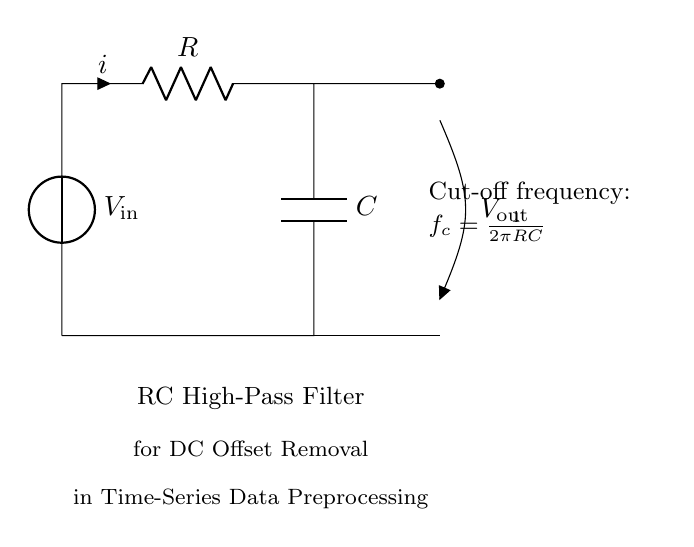What is the input voltage of the circuit? The input voltage is represented as V_in at the top of the voltage source in the circuit.
Answer: V_in What components are used in the circuit? The circuit consists of a voltage source, a resistor, and a capacitor, as depicted in the diagram.
Answer: Voltage source, resistor, capacitor What does the current direction indicate? The direction indicated by the arrow on the resistor shows the flow of current from the voltage source through the resistor and towards the capacitor.
Answer: From the voltage source through the resistor to the capacitor What is the formula for the cut-off frequency? The cut-off frequency, shown in the diagram, is given by the formula f_c = 1 / (2πRC), which relates R and C to the frequency.
Answer: f_c = 1 / (2πRC) What happens to signals below the cut-off frequency? Signals with frequencies lower than the cut-off frequency are attenuated by the filter, which is characteristic of a high-pass filter.
Answer: Attenuated Why is this RC circuit used for DC offset removal? The RC high-pass filter is designed to block DC components (0 Hz) while allowing higher frequency signals to pass, thus effectively removing the DC offset from the time-series data.
Answer: To remove DC offset 